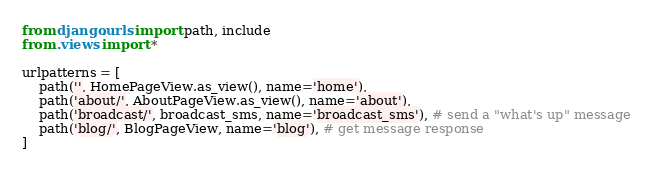<code> <loc_0><loc_0><loc_500><loc_500><_Python_>from django.urls import path, include
from .views import *

urlpatterns = [
    path('', HomePageView.as_view(), name='home'),
    path('about/', AboutPageView.as_view(), name='about'),
    path('broadcast/', broadcast_sms, name='broadcast_sms'), # send a "what's up" message
    path('blog/', BlogPageView, name='blog'), # get message response
]

</code> 